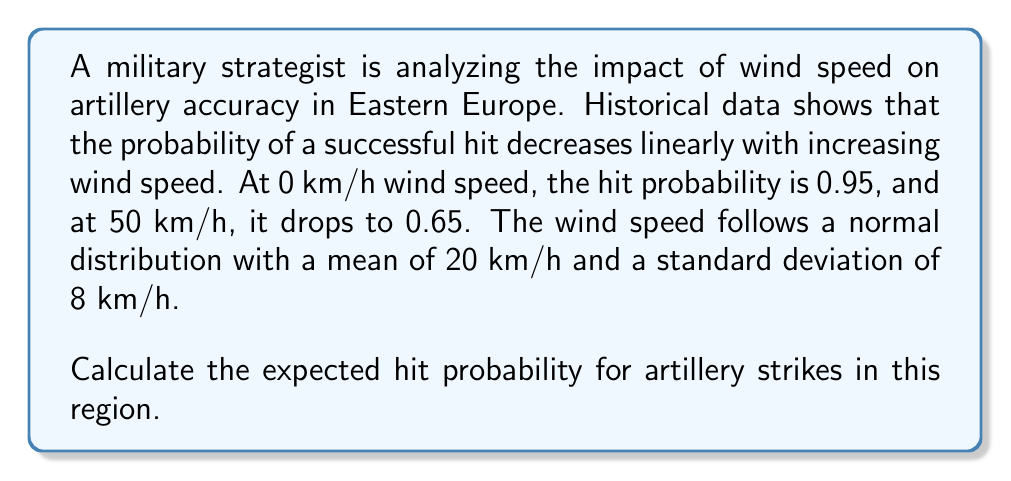Teach me how to tackle this problem. To solve this problem, we need to follow these steps:

1) First, let's define the linear relationship between wind speed and hit probability:

   Let $P(x)$ be the hit probability at wind speed $x$.
   
   $$P(x) = ax + b$$

   where $a$ is the slope and $b$ is the y-intercept.

2) We can find $a$ and $b$ using the given points (0, 0.95) and (50, 0.65):

   $$a = \frac{0.65 - 0.95}{50 - 0} = -0.006$$
   $$b = 0.95$$

   So, $$P(x) = -0.006x + 0.95$$

3) The wind speed follows a normal distribution:
   $X \sim N(\mu = 20, \sigma = 8)$

4) The expected hit probability is:

   $$E[P(X)] = E[-0.006X + 0.95]$$

5) Using the linearity of expectation:

   $$E[P(X)] = -0.006E[X] + 0.95$$

6) We know that $E[X] = \mu = 20$ for a normal distribution.

7) Substituting this:

   $$E[P(X)] = -0.006(20) + 0.95 = 0.83$$

Therefore, the expected hit probability is 0.83 or 83%.
Answer: 0.83 or 83% 